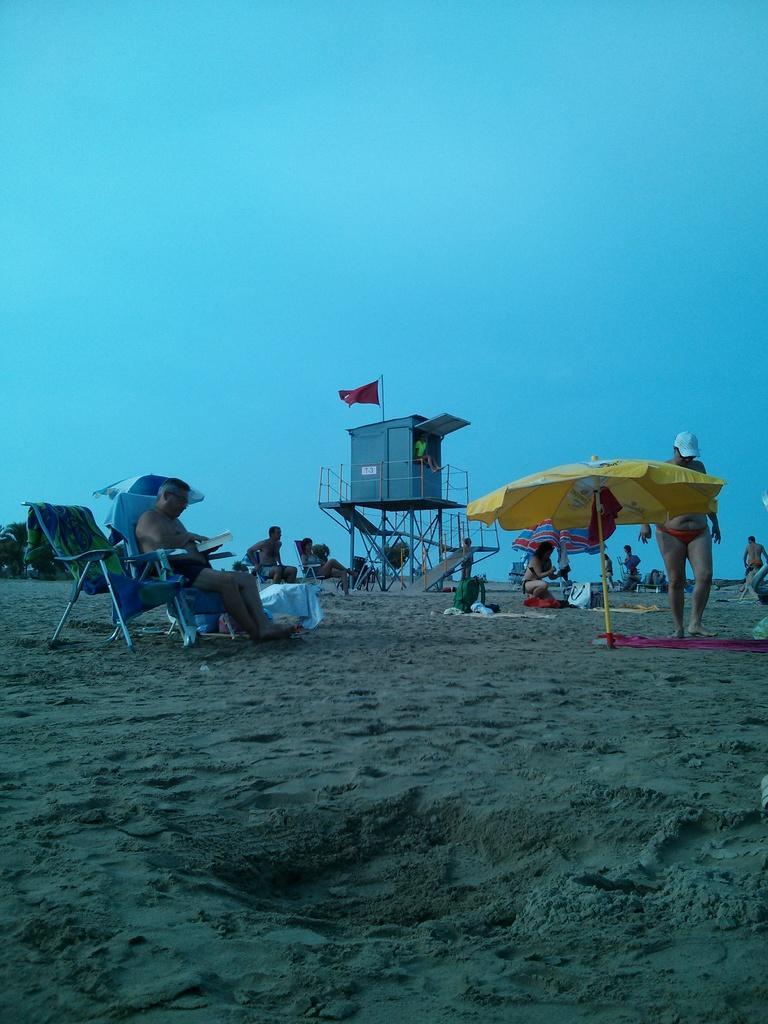How would you summarize this image in a sentence or two? On the left side of the image we can see people on the chaise lounges. On the right there are people standing and walking. There are parasols. In the background there is a cabin and we can see a flag on it. In the background there is sky. At the bottom there is sand. 